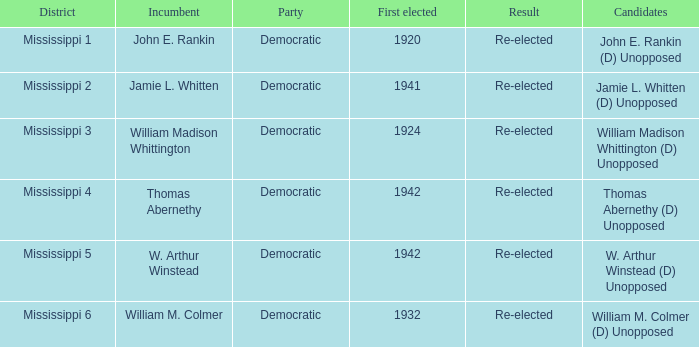What is the district of origin for jamie l. whitten? Mississippi 2. 